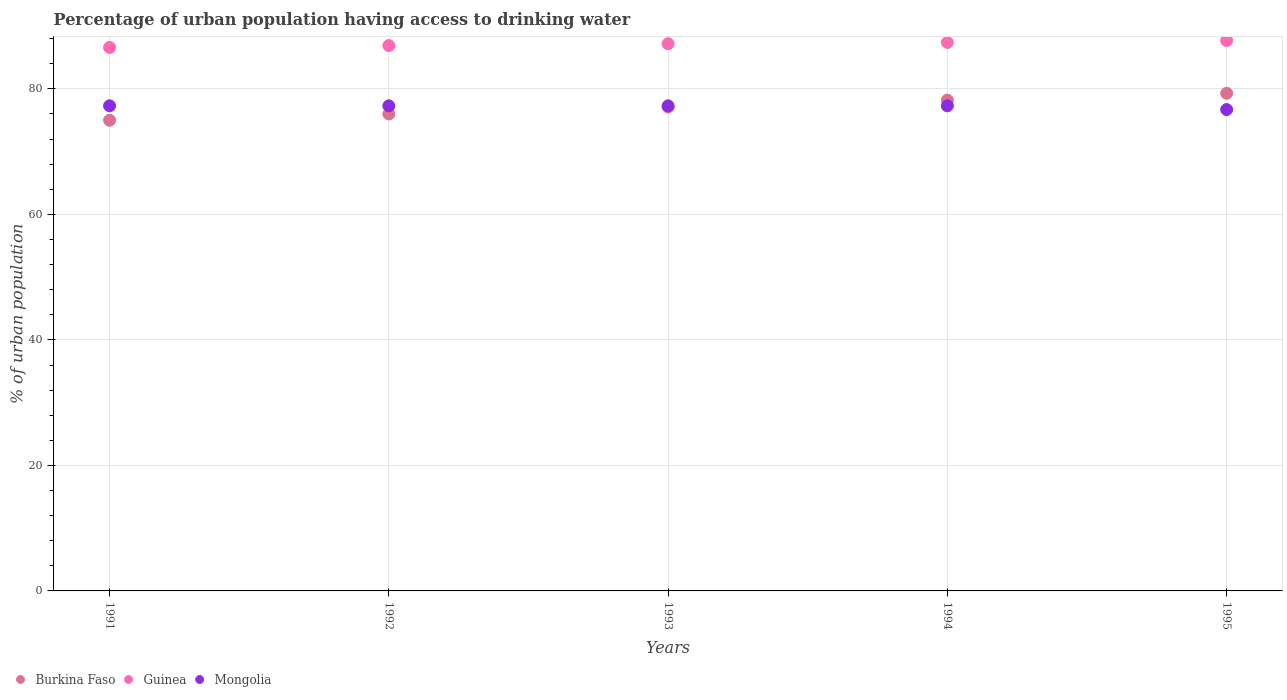How many different coloured dotlines are there?
Offer a very short reply. 3. What is the percentage of urban population having access to drinking water in Guinea in 1992?
Give a very brief answer. 86.9. Across all years, what is the maximum percentage of urban population having access to drinking water in Guinea?
Ensure brevity in your answer.  87.7. Across all years, what is the minimum percentage of urban population having access to drinking water in Guinea?
Offer a terse response. 86.6. In which year was the percentage of urban population having access to drinking water in Burkina Faso maximum?
Offer a very short reply. 1995. In which year was the percentage of urban population having access to drinking water in Guinea minimum?
Make the answer very short. 1991. What is the total percentage of urban population having access to drinking water in Guinea in the graph?
Give a very brief answer. 435.8. What is the difference between the percentage of urban population having access to drinking water in Mongolia in 1992 and that in 1995?
Make the answer very short. 0.6. What is the difference between the percentage of urban population having access to drinking water in Burkina Faso in 1993 and the percentage of urban population having access to drinking water in Guinea in 1995?
Ensure brevity in your answer.  -10.6. What is the average percentage of urban population having access to drinking water in Burkina Faso per year?
Your answer should be compact. 77.12. In the year 1991, what is the difference between the percentage of urban population having access to drinking water in Guinea and percentage of urban population having access to drinking water in Burkina Faso?
Keep it short and to the point. 11.6. Is the percentage of urban population having access to drinking water in Mongolia in 1993 less than that in 1995?
Make the answer very short. No. What is the difference between the highest and the second highest percentage of urban population having access to drinking water in Guinea?
Provide a succinct answer. 0.3. What is the difference between the highest and the lowest percentage of urban population having access to drinking water in Burkina Faso?
Give a very brief answer. 4.3. Is it the case that in every year, the sum of the percentage of urban population having access to drinking water in Guinea and percentage of urban population having access to drinking water in Burkina Faso  is greater than the percentage of urban population having access to drinking water in Mongolia?
Make the answer very short. Yes. Does the percentage of urban population having access to drinking water in Mongolia monotonically increase over the years?
Provide a succinct answer. No. Is the percentage of urban population having access to drinking water in Guinea strictly greater than the percentage of urban population having access to drinking water in Burkina Faso over the years?
Your answer should be very brief. Yes. How many years are there in the graph?
Keep it short and to the point. 5. Are the values on the major ticks of Y-axis written in scientific E-notation?
Your response must be concise. No. Does the graph contain any zero values?
Your answer should be compact. No. Does the graph contain grids?
Your answer should be very brief. Yes. How many legend labels are there?
Ensure brevity in your answer.  3. How are the legend labels stacked?
Offer a terse response. Horizontal. What is the title of the graph?
Ensure brevity in your answer.  Percentage of urban population having access to drinking water. What is the label or title of the Y-axis?
Provide a succinct answer. % of urban population. What is the % of urban population of Burkina Faso in 1991?
Keep it short and to the point. 75. What is the % of urban population of Guinea in 1991?
Keep it short and to the point. 86.6. What is the % of urban population of Mongolia in 1991?
Provide a short and direct response. 77.3. What is the % of urban population in Guinea in 1992?
Make the answer very short. 86.9. What is the % of urban population in Mongolia in 1992?
Offer a terse response. 77.3. What is the % of urban population in Burkina Faso in 1993?
Give a very brief answer. 77.1. What is the % of urban population of Guinea in 1993?
Give a very brief answer. 87.2. What is the % of urban population of Mongolia in 1993?
Your answer should be compact. 77.3. What is the % of urban population of Burkina Faso in 1994?
Your answer should be compact. 78.2. What is the % of urban population of Guinea in 1994?
Your answer should be compact. 87.4. What is the % of urban population of Mongolia in 1994?
Give a very brief answer. 77.3. What is the % of urban population in Burkina Faso in 1995?
Offer a terse response. 79.3. What is the % of urban population in Guinea in 1995?
Offer a very short reply. 87.7. What is the % of urban population of Mongolia in 1995?
Make the answer very short. 76.7. Across all years, what is the maximum % of urban population of Burkina Faso?
Your answer should be very brief. 79.3. Across all years, what is the maximum % of urban population of Guinea?
Provide a succinct answer. 87.7. Across all years, what is the maximum % of urban population of Mongolia?
Your answer should be very brief. 77.3. Across all years, what is the minimum % of urban population of Guinea?
Make the answer very short. 86.6. Across all years, what is the minimum % of urban population in Mongolia?
Offer a terse response. 76.7. What is the total % of urban population of Burkina Faso in the graph?
Give a very brief answer. 385.6. What is the total % of urban population of Guinea in the graph?
Make the answer very short. 435.8. What is the total % of urban population of Mongolia in the graph?
Your answer should be compact. 385.9. What is the difference between the % of urban population in Guinea in 1991 and that in 1992?
Make the answer very short. -0.3. What is the difference between the % of urban population of Guinea in 1991 and that in 1993?
Offer a very short reply. -0.6. What is the difference between the % of urban population in Burkina Faso in 1991 and that in 1994?
Your answer should be very brief. -3.2. What is the difference between the % of urban population of Guinea in 1991 and that in 1994?
Your answer should be very brief. -0.8. What is the difference between the % of urban population in Guinea in 1991 and that in 1995?
Your answer should be compact. -1.1. What is the difference between the % of urban population in Burkina Faso in 1992 and that in 1993?
Give a very brief answer. -1.1. What is the difference between the % of urban population of Guinea in 1992 and that in 1994?
Offer a very short reply. -0.5. What is the difference between the % of urban population in Mongolia in 1992 and that in 1994?
Give a very brief answer. 0. What is the difference between the % of urban population in Burkina Faso in 1992 and that in 1995?
Offer a very short reply. -3.3. What is the difference between the % of urban population in Guinea in 1993 and that in 1994?
Your answer should be compact. -0.2. What is the difference between the % of urban population of Mongolia in 1993 and that in 1994?
Your answer should be compact. 0. What is the difference between the % of urban population in Guinea in 1993 and that in 1995?
Your response must be concise. -0.5. What is the difference between the % of urban population of Burkina Faso in 1994 and that in 1995?
Keep it short and to the point. -1.1. What is the difference between the % of urban population of Burkina Faso in 1991 and the % of urban population of Mongolia in 1992?
Provide a succinct answer. -2.3. What is the difference between the % of urban population in Burkina Faso in 1991 and the % of urban population in Guinea in 1993?
Provide a succinct answer. -12.2. What is the difference between the % of urban population of Burkina Faso in 1991 and the % of urban population of Mongolia in 1994?
Give a very brief answer. -2.3. What is the difference between the % of urban population in Burkina Faso in 1991 and the % of urban population in Guinea in 1995?
Keep it short and to the point. -12.7. What is the difference between the % of urban population in Guinea in 1991 and the % of urban population in Mongolia in 1995?
Keep it short and to the point. 9.9. What is the difference between the % of urban population of Burkina Faso in 1992 and the % of urban population of Guinea in 1993?
Offer a terse response. -11.2. What is the difference between the % of urban population in Burkina Faso in 1992 and the % of urban population in Mongolia in 1993?
Keep it short and to the point. -1.3. What is the difference between the % of urban population of Burkina Faso in 1992 and the % of urban population of Guinea in 1994?
Keep it short and to the point. -11.4. What is the difference between the % of urban population in Burkina Faso in 1992 and the % of urban population in Mongolia in 1994?
Your answer should be compact. -1.3. What is the difference between the % of urban population of Burkina Faso in 1992 and the % of urban population of Guinea in 1995?
Keep it short and to the point. -11.7. What is the difference between the % of urban population of Burkina Faso in 1992 and the % of urban population of Mongolia in 1995?
Your response must be concise. -0.7. What is the difference between the % of urban population of Guinea in 1992 and the % of urban population of Mongolia in 1995?
Provide a succinct answer. 10.2. What is the difference between the % of urban population of Burkina Faso in 1993 and the % of urban population of Guinea in 1994?
Your response must be concise. -10.3. What is the difference between the % of urban population in Burkina Faso in 1993 and the % of urban population in Guinea in 1995?
Your answer should be compact. -10.6. What is the difference between the % of urban population in Burkina Faso in 1993 and the % of urban population in Mongolia in 1995?
Give a very brief answer. 0.4. What is the difference between the % of urban population in Burkina Faso in 1994 and the % of urban population in Guinea in 1995?
Offer a very short reply. -9.5. What is the difference between the % of urban population in Burkina Faso in 1994 and the % of urban population in Mongolia in 1995?
Provide a short and direct response. 1.5. What is the average % of urban population in Burkina Faso per year?
Provide a succinct answer. 77.12. What is the average % of urban population in Guinea per year?
Provide a succinct answer. 87.16. What is the average % of urban population in Mongolia per year?
Your response must be concise. 77.18. In the year 1992, what is the difference between the % of urban population in Guinea and % of urban population in Mongolia?
Your answer should be compact. 9.6. In the year 1993, what is the difference between the % of urban population of Burkina Faso and % of urban population of Guinea?
Make the answer very short. -10.1. In the year 1993, what is the difference between the % of urban population in Guinea and % of urban population in Mongolia?
Give a very brief answer. 9.9. In the year 1994, what is the difference between the % of urban population in Burkina Faso and % of urban population in Mongolia?
Your response must be concise. 0.9. In the year 1995, what is the difference between the % of urban population in Burkina Faso and % of urban population in Mongolia?
Your answer should be very brief. 2.6. What is the ratio of the % of urban population of Burkina Faso in 1991 to that in 1992?
Your answer should be very brief. 0.99. What is the ratio of the % of urban population in Guinea in 1991 to that in 1992?
Give a very brief answer. 1. What is the ratio of the % of urban population in Mongolia in 1991 to that in 1992?
Your response must be concise. 1. What is the ratio of the % of urban population in Burkina Faso in 1991 to that in 1993?
Your answer should be compact. 0.97. What is the ratio of the % of urban population of Burkina Faso in 1991 to that in 1994?
Offer a terse response. 0.96. What is the ratio of the % of urban population of Mongolia in 1991 to that in 1994?
Give a very brief answer. 1. What is the ratio of the % of urban population of Burkina Faso in 1991 to that in 1995?
Your response must be concise. 0.95. What is the ratio of the % of urban population in Guinea in 1991 to that in 1995?
Provide a succinct answer. 0.99. What is the ratio of the % of urban population of Burkina Faso in 1992 to that in 1993?
Your answer should be very brief. 0.99. What is the ratio of the % of urban population in Mongolia in 1992 to that in 1993?
Keep it short and to the point. 1. What is the ratio of the % of urban population in Burkina Faso in 1992 to that in 1994?
Provide a short and direct response. 0.97. What is the ratio of the % of urban population of Guinea in 1992 to that in 1994?
Keep it short and to the point. 0.99. What is the ratio of the % of urban population of Burkina Faso in 1992 to that in 1995?
Offer a very short reply. 0.96. What is the ratio of the % of urban population in Guinea in 1992 to that in 1995?
Provide a succinct answer. 0.99. What is the ratio of the % of urban population in Mongolia in 1992 to that in 1995?
Give a very brief answer. 1.01. What is the ratio of the % of urban population in Burkina Faso in 1993 to that in 1994?
Offer a very short reply. 0.99. What is the ratio of the % of urban population of Guinea in 1993 to that in 1994?
Make the answer very short. 1. What is the ratio of the % of urban population of Mongolia in 1993 to that in 1994?
Provide a short and direct response. 1. What is the ratio of the % of urban population of Burkina Faso in 1993 to that in 1995?
Give a very brief answer. 0.97. What is the ratio of the % of urban population in Burkina Faso in 1994 to that in 1995?
Your answer should be very brief. 0.99. What is the ratio of the % of urban population in Mongolia in 1994 to that in 1995?
Your answer should be very brief. 1.01. What is the difference between the highest and the second highest % of urban population in Mongolia?
Provide a short and direct response. 0. 